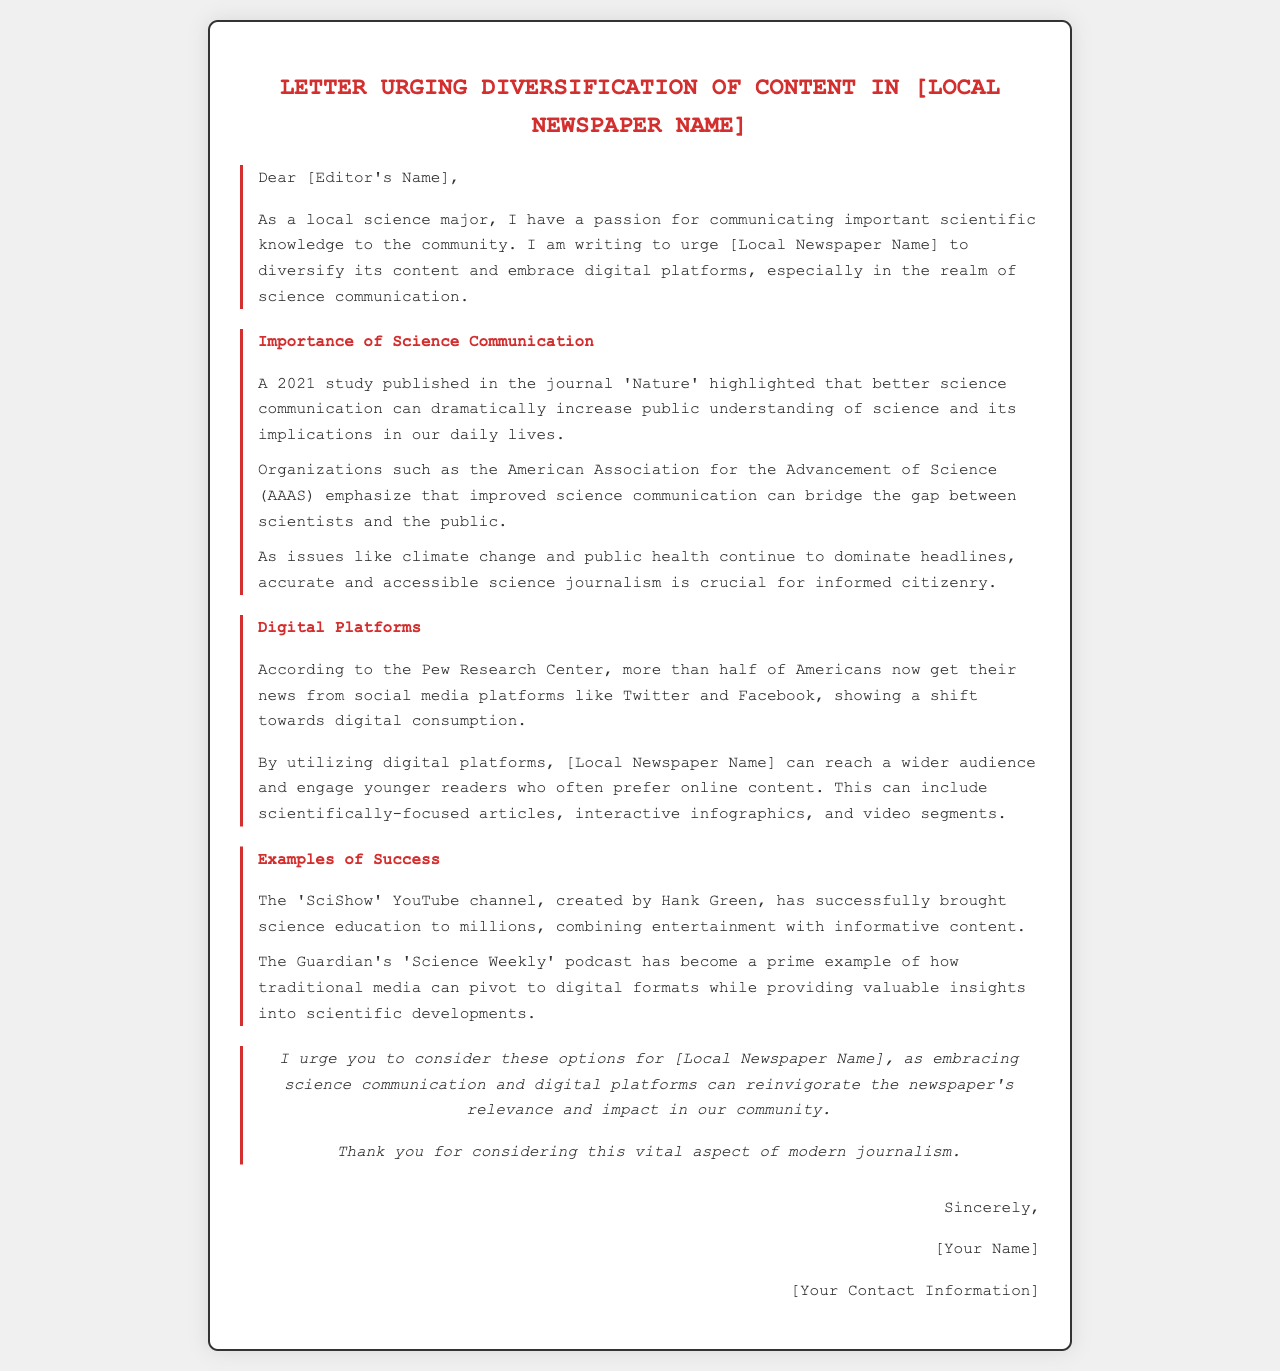What is the main purpose of the letter? The letter urges the local newspaper to diversify its content and embrace digital platforms, focusing on science communication.
Answer: Diversify content Who is the author of the letter? The letter is signed by the individual who is a local science major.
Answer: [Your Name] Which organization emphasizes improved science communication? The American Association for the Advancement of Science (AAAS) emphasizes improved science communication to bridge the gap between scientists and the public.
Answer: AAAS What year was the study published that is mentioned in the letter? The study highlighted in the letter was published in 2021.
Answer: 2021 What digital platforms are mentioned as popular news sources? Social media platforms like Twitter and Facebook are mentioned as popular news sources.
Answer: Twitter and Facebook Which YouTube channel is cited as a successful example of science communication? The 'SciShow' YouTube channel is cited as a successful example of science communication.
Answer: SciShow What type of content does the letter suggest for engaging younger readers? The letter suggests scientifically-focused articles, interactive infographics, and video segments to engage younger readers.
Answer: Scientifically-focused articles What does the author hope the newspaper will consider? The author hopes the newspaper will consider embracing science communication and digital platforms.
Answer: Embracing science communication In what context is the 'Science Weekly' podcast mentioned? It is mentioned as an example of how traditional media can pivot to digital formats while providing valuable insights.
Answer: Traditional media pivot to digital formats 